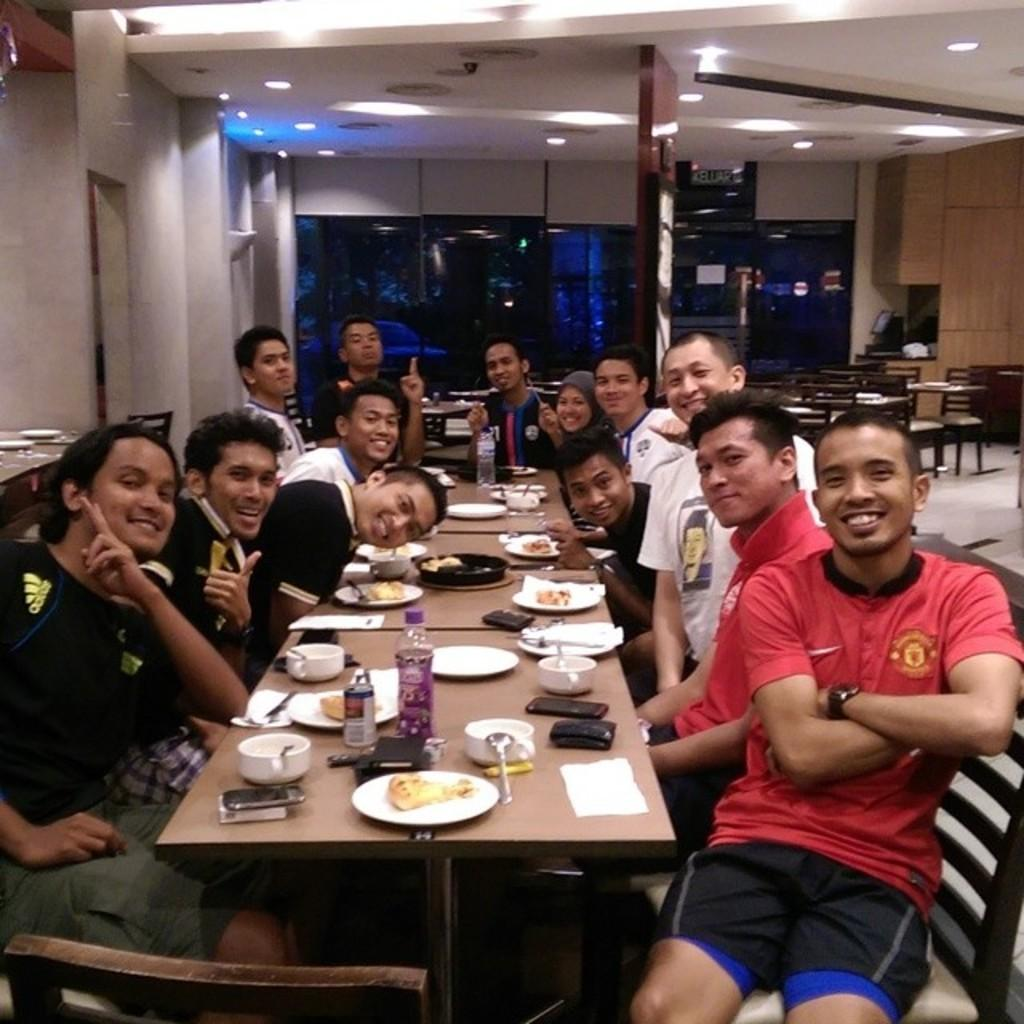How many people are in the image? There is a group of persons in the image. What are the persons in the image doing? The persons are sitting around a table. What is the emotional expression of the persons in the image? The persons are smiling. What can be seen in the background of the image? There is a wall and a light in the background of the image. What is the name of the father in the image? There is no mention of a father or any specific person's name in the image. 